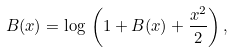<formula> <loc_0><loc_0><loc_500><loc_500>B ( x ) = \log \, \left ( 1 + B ( x ) + \frac { x ^ { 2 } } { 2 } \right ) ,</formula> 